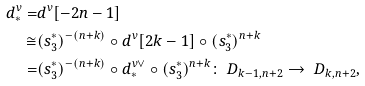Convert formula to latex. <formula><loc_0><loc_0><loc_500><loc_500>d ^ { v } _ { * } = & d ^ { v } [ - 2 n - 1 ] \\ \cong & ( s _ { 3 } ^ { * } ) ^ { - ( n + k ) } \circ d ^ { v } [ 2 k - 1 ] \circ ( s _ { 3 } ^ { * } ) ^ { n + k } \\ = & ( s _ { 3 } ^ { * } ) ^ { - ( n + k ) } \circ d ^ { v \vee } _ { * } \circ ( s _ { 3 } ^ { * } ) ^ { n + k } \colon \ D _ { k - 1 , n + 2 } \to \ D _ { k , n + 2 } ,</formula> 